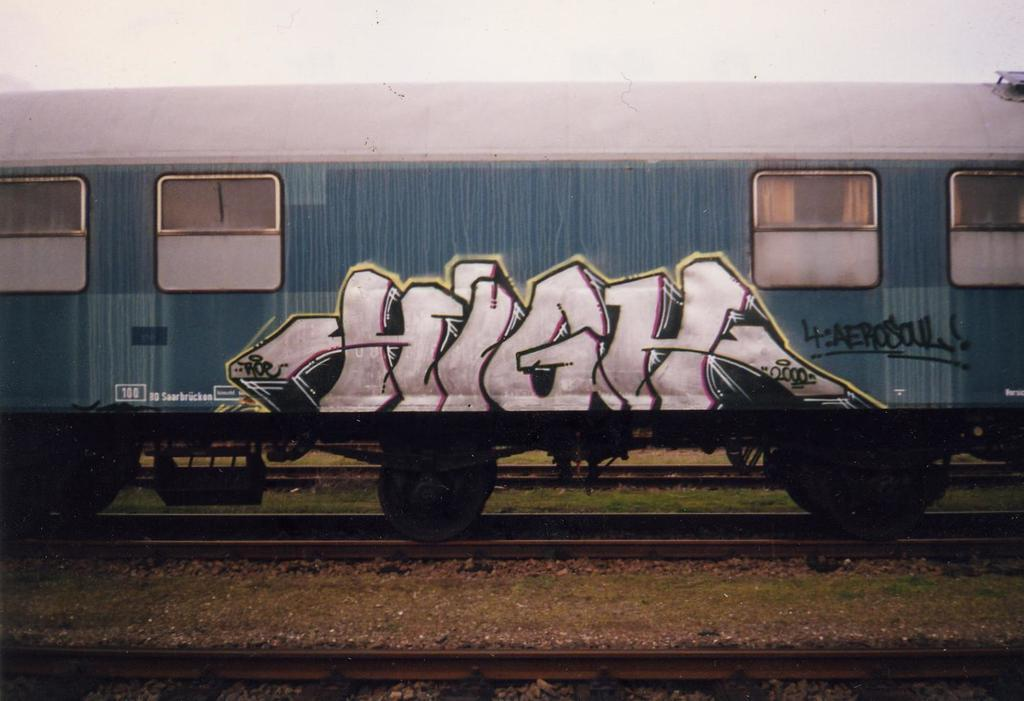<image>
Share a concise interpretation of the image provided. a train car has the word HIGH graffitied on it 